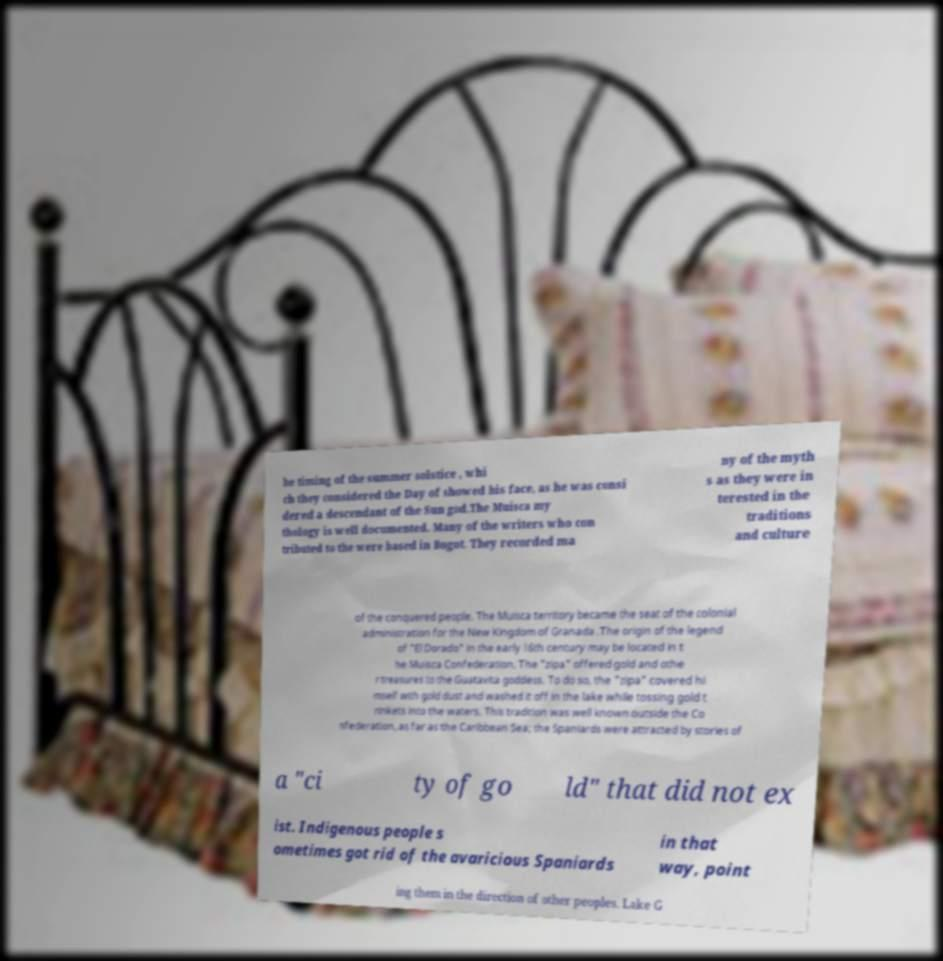For documentation purposes, I need the text within this image transcribed. Could you provide that? he timing of the summer solstice , whi ch they considered the Day of showed his face, as he was consi dered a descendant of the Sun god.The Muisca my thology is well documented. Many of the writers who con tributed to the were based in Bogot. They recorded ma ny of the myth s as they were in terested in the traditions and culture of the conquered people. The Muisca territory became the seat of the colonial administration for the New Kingdom of Granada .The origin of the legend of "El Dorado" in the early 16th century may be located in t he Muisca Confederation. The "zipa" offered gold and othe r treasures to the Guatavita goddess. To do so, the "zipa" covered hi mself with gold dust and washed it off in the lake while tossing gold t rinkets into the waters. This tradition was well known outside the Co nfederation, as far as the Caribbean Sea; the Spaniards were attracted by stories of a "ci ty of go ld" that did not ex ist. Indigenous people s ometimes got rid of the avaricious Spaniards in that way, point ing them in the direction of other peoples. Lake G 